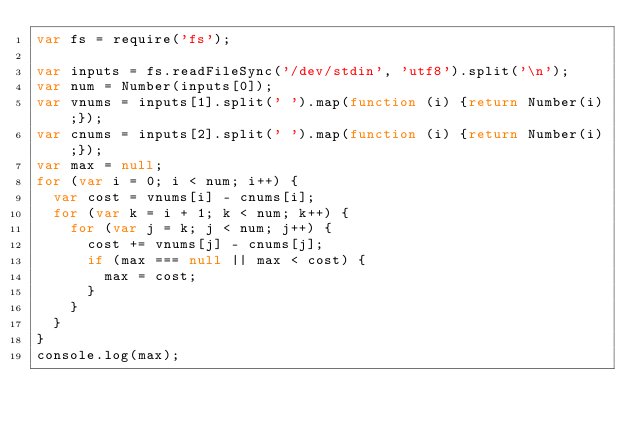Convert code to text. <code><loc_0><loc_0><loc_500><loc_500><_JavaScript_>var fs = require('fs');
 
var inputs = fs.readFileSync('/dev/stdin', 'utf8').split('\n');
var num = Number(inputs[0]);
var vnums = inputs[1].split(' ').map(function (i) {return Number(i);});
var cnums = inputs[2].split(' ').map(function (i) {return Number(i);});
var max = null;
for (var i = 0; i < num; i++) {
  var cost = vnums[i] - cnums[i];
  for (var k = i + 1; k < num; k++) {
    for (var j = k; j < num; j++) {
      cost += vnums[j] - cnums[j];
      if (max === null || max < cost) {
        max = cost;
      }
    }
  }
}
console.log(max);
</code> 